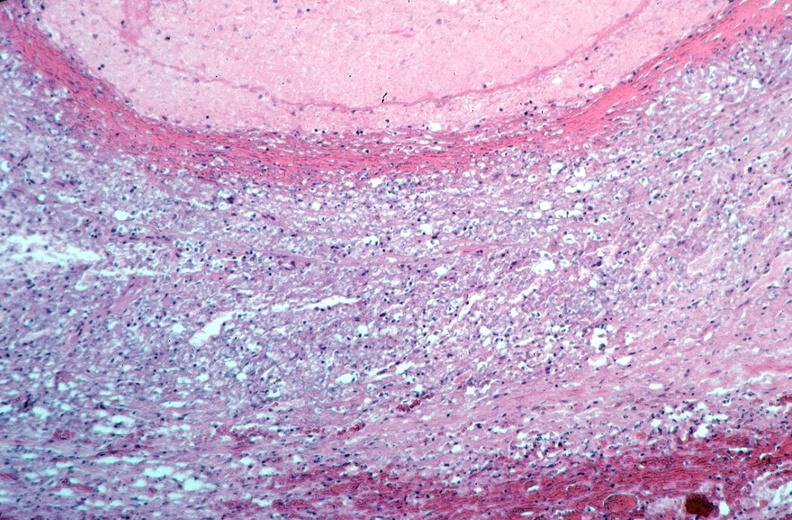what is present?
Answer the question using a single word or phrase. Vasculature 